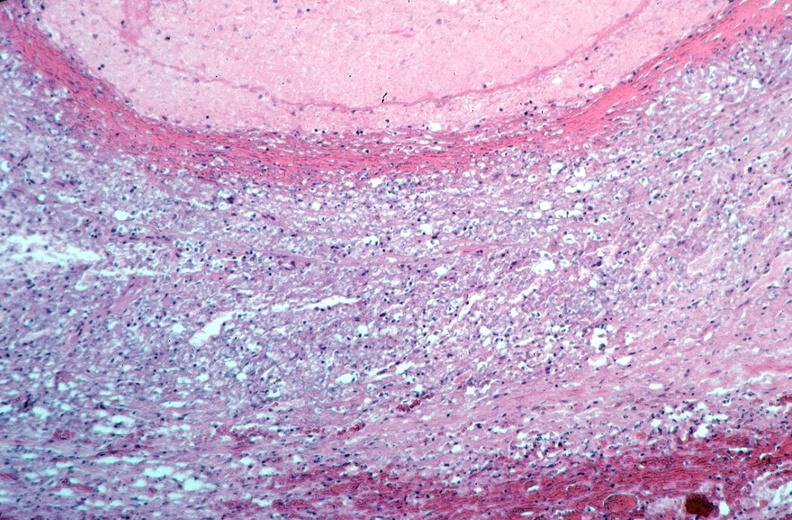what is present?
Answer the question using a single word or phrase. Vasculature 